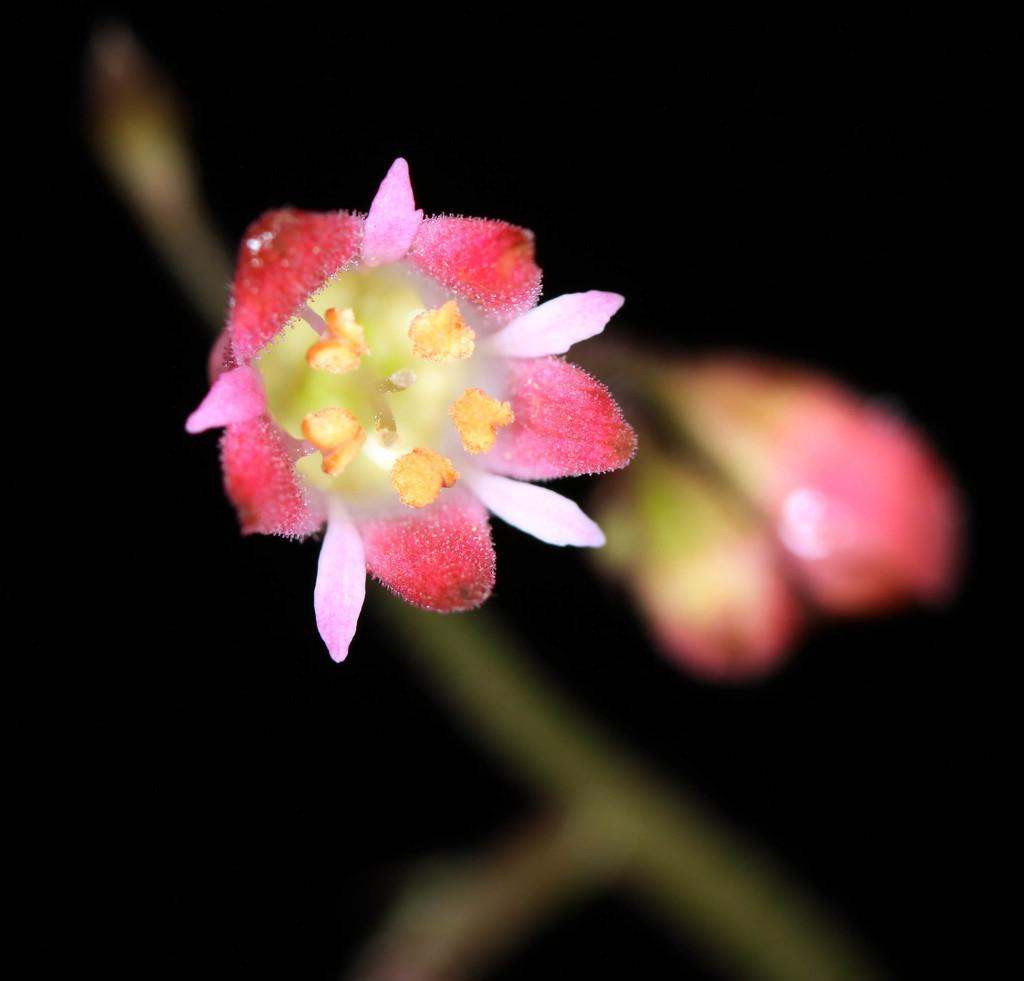What is the main subject in the front of the image? There is a flower in the front of the image. How would you describe the background of the image? The background of the image is blurry and dark. What can be seen connected to the flower in the image? There is a stem in the image. Are there any other flowers visible in the image? Yes, there is another flower in the image. How does the flower express anger in the image? The flower does not express anger in the image, as it is an inanimate object and cannot display emotions. 